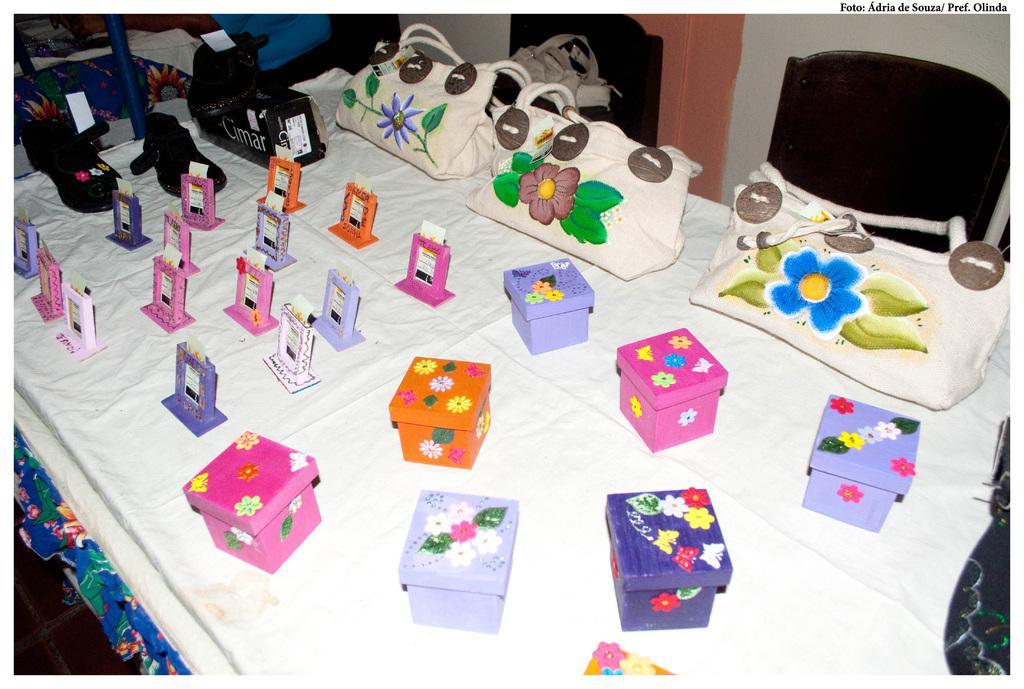Describe this image in one or two sentences. On the white color cloth there are some boxes with orange,pink and blue color. and to the left side there are some handmade photo frames. And on the top there are handbag with flower painting on it. And to the top there are three shoes which are in black color. 